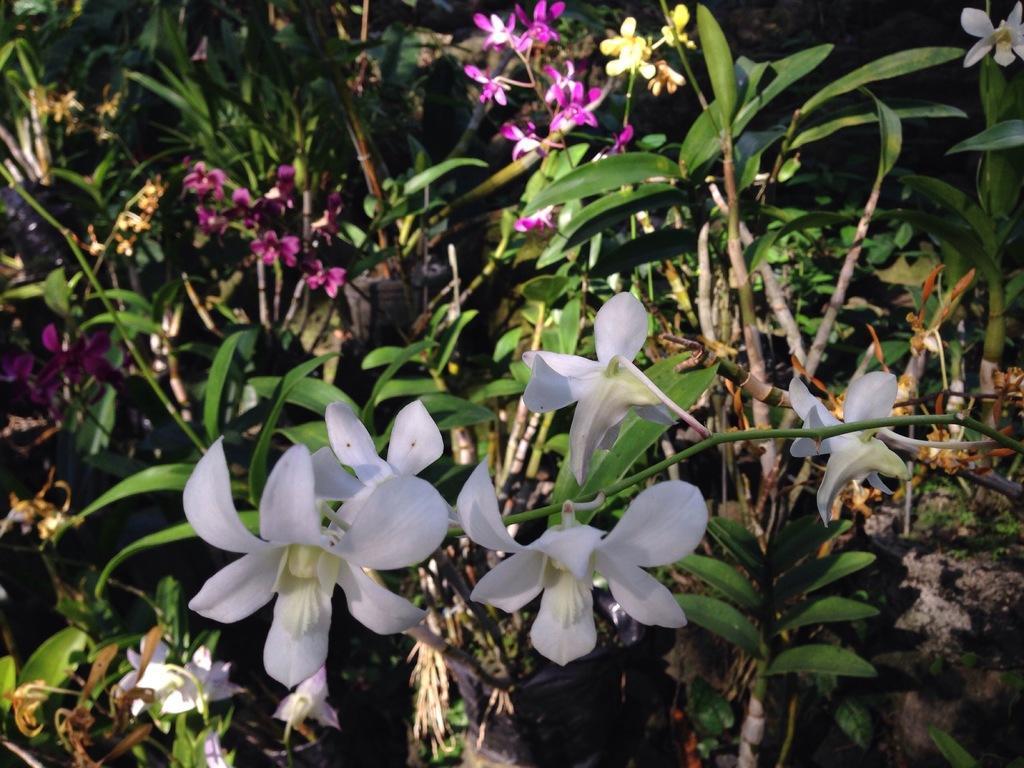Could you give a brief overview of what you see in this image? In the image we can see there are flowers on the plant. There are white colour and pink colour flowers. 